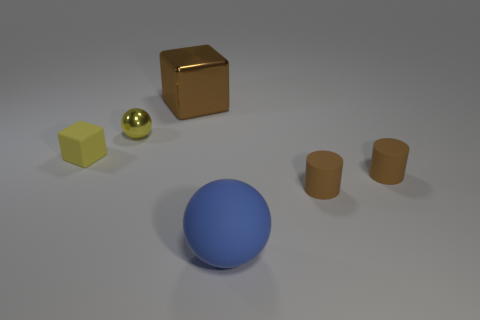There is a sphere that is the same color as the small block; what is its material?
Ensure brevity in your answer.  Metal. What number of other things are the same color as the large shiny cube?
Ensure brevity in your answer.  2. What size is the ball that is the same color as the tiny block?
Provide a short and direct response. Small. There is a yellow thing on the left side of the yellow shiny sphere; is it the same shape as the brown object behind the matte cube?
Offer a terse response. Yes. Are there any balls made of the same material as the big brown thing?
Provide a short and direct response. Yes. How many blue things are either rubber cubes or rubber spheres?
Offer a terse response. 1. There is a thing that is both on the right side of the small yellow ball and left of the blue matte sphere; what size is it?
Provide a short and direct response. Large. Are there more blocks that are left of the brown shiny cube than small matte cubes?
Ensure brevity in your answer.  No. How many cylinders are either big objects or large purple objects?
Your answer should be very brief. 0. The thing that is both left of the large cube and in front of the small yellow metallic ball has what shape?
Make the answer very short. Cube. 